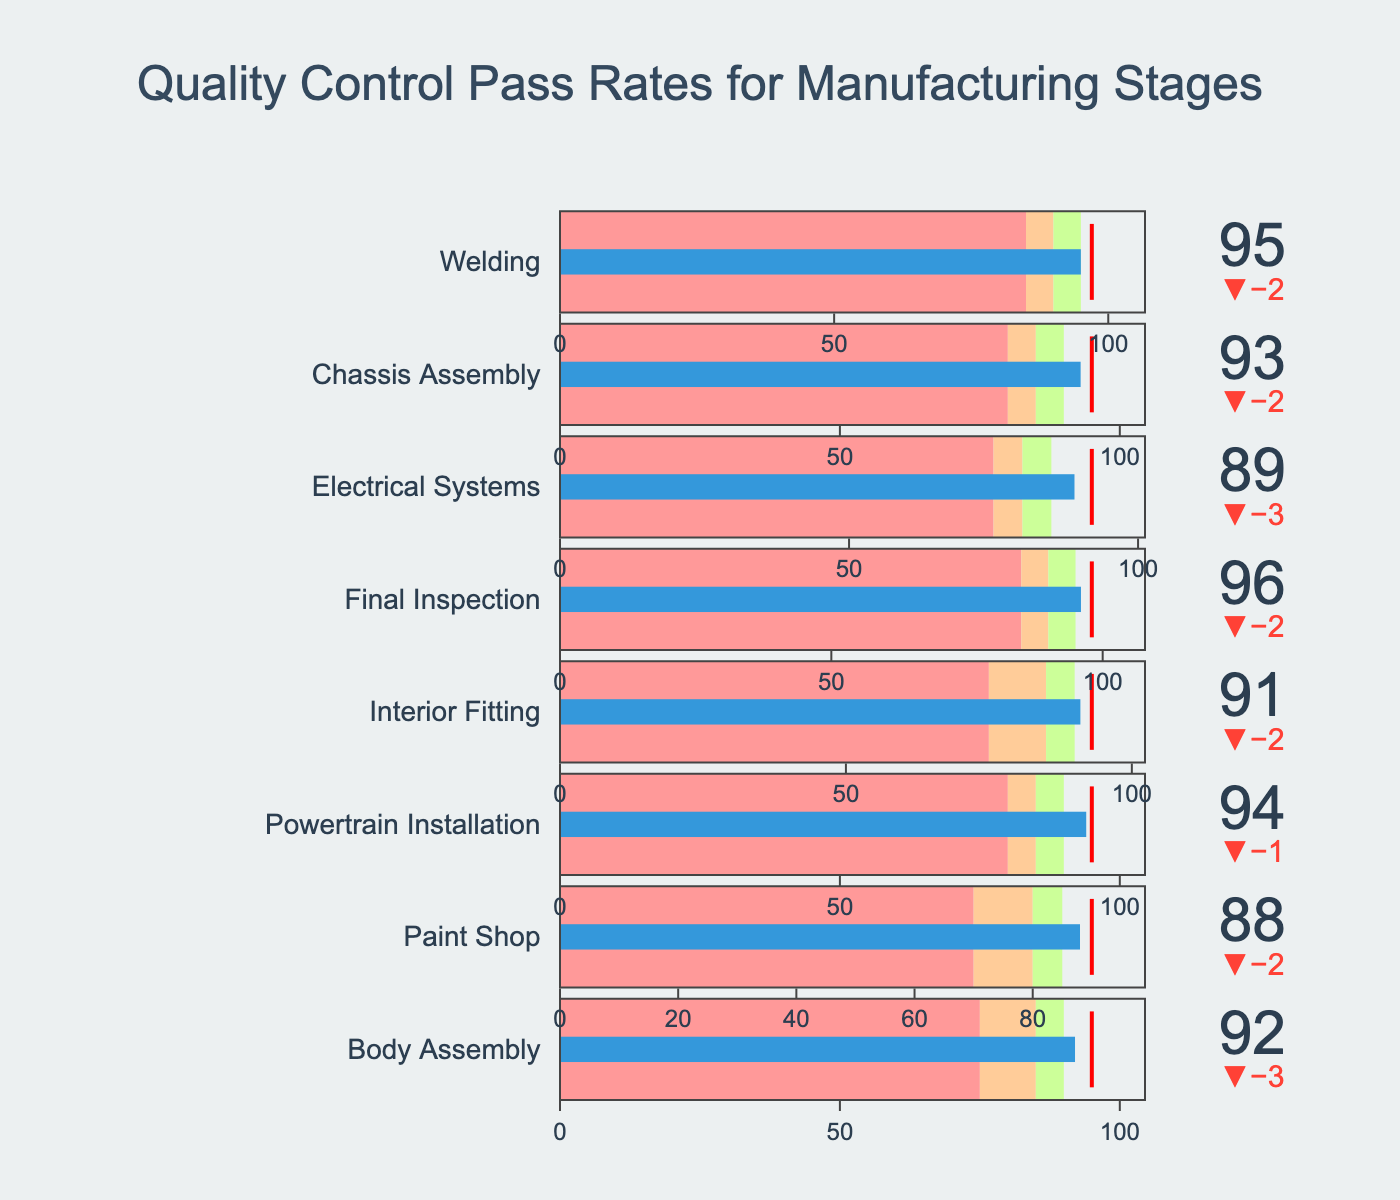What's the title of the figure? The title is located at the top of the figure, describing the main focus of the chart.
Answer: Quality Control Pass Rates for Manufacturing Stages How many manufacturing stages are displayed in the figure? Count the number of different stages listed vertically in the figure. There are 8 different sections, each representing a manufacturing stage.
Answer: 8 Which manufacturing stage has the highest actual pass rate? Look for the bar that extends the furthest to the right in the figure. The "Final Inspection" stage has an actual pass rate of 96, the highest among all.
Answer: Final Inspection Which stages have their actual pass rates meeting or exceeding their targets? Compare the length of each bar to its target marker. Only two stages meet or exceed their targets: "Welding" and "Final Inspection".
Answer: Welding, Final Inspection What is the pass rate difference between the 'Paint Shop' and 'Electrical Systems'? Subtract the actual pass rate of 'Electrical Systems' from 'Paint Shop'. The difference is 88 (Paint Shop) - 89 (Electrical Systems) = -1.
Answer: -1 In which stages did the actual pass rate fall short of the target pass rate by more than 5 points? For each stage, subtract the actual pass rate from the target pass rate and check if the result is greater than 5. "Paint Shop" (88 vs. 90, difference 2) and "Interior Fitting" (91 vs. 93, difference 2) meet this condition.
Answer: None Compare the actual pass rates between 'Body Assembly' and 'Powertrain Installation' and indicate which is higher. Compare the actual pass rate values. 'Powertrain Installation' has a higher actual pass rate (94) than 'Body Assembly' (92).
Answer: Powertrain Installation What is the average target pass rate for all stages? Sum up all target pass rates and divide by the number of stages. (95 + 90 + 95 + 93 + 98 + 92 + 95 + 97) / 8 = 93.125
Answer: 93.125 Which stage has the smallest difference between its actual and target pass rate? Calculate the difference between actual and target pass rates for each stage and find the smallest. 'Chassis Assembly' has the smallest difference, with a difference of 93 - 95 = -2.
Answer: Chassis Assembly What color represents the range between 85 and 90 in the figure? Identify the color of the bar section corresponding to this range in any of the bullet charts. This color is the light green shade.
Answer: Light green 